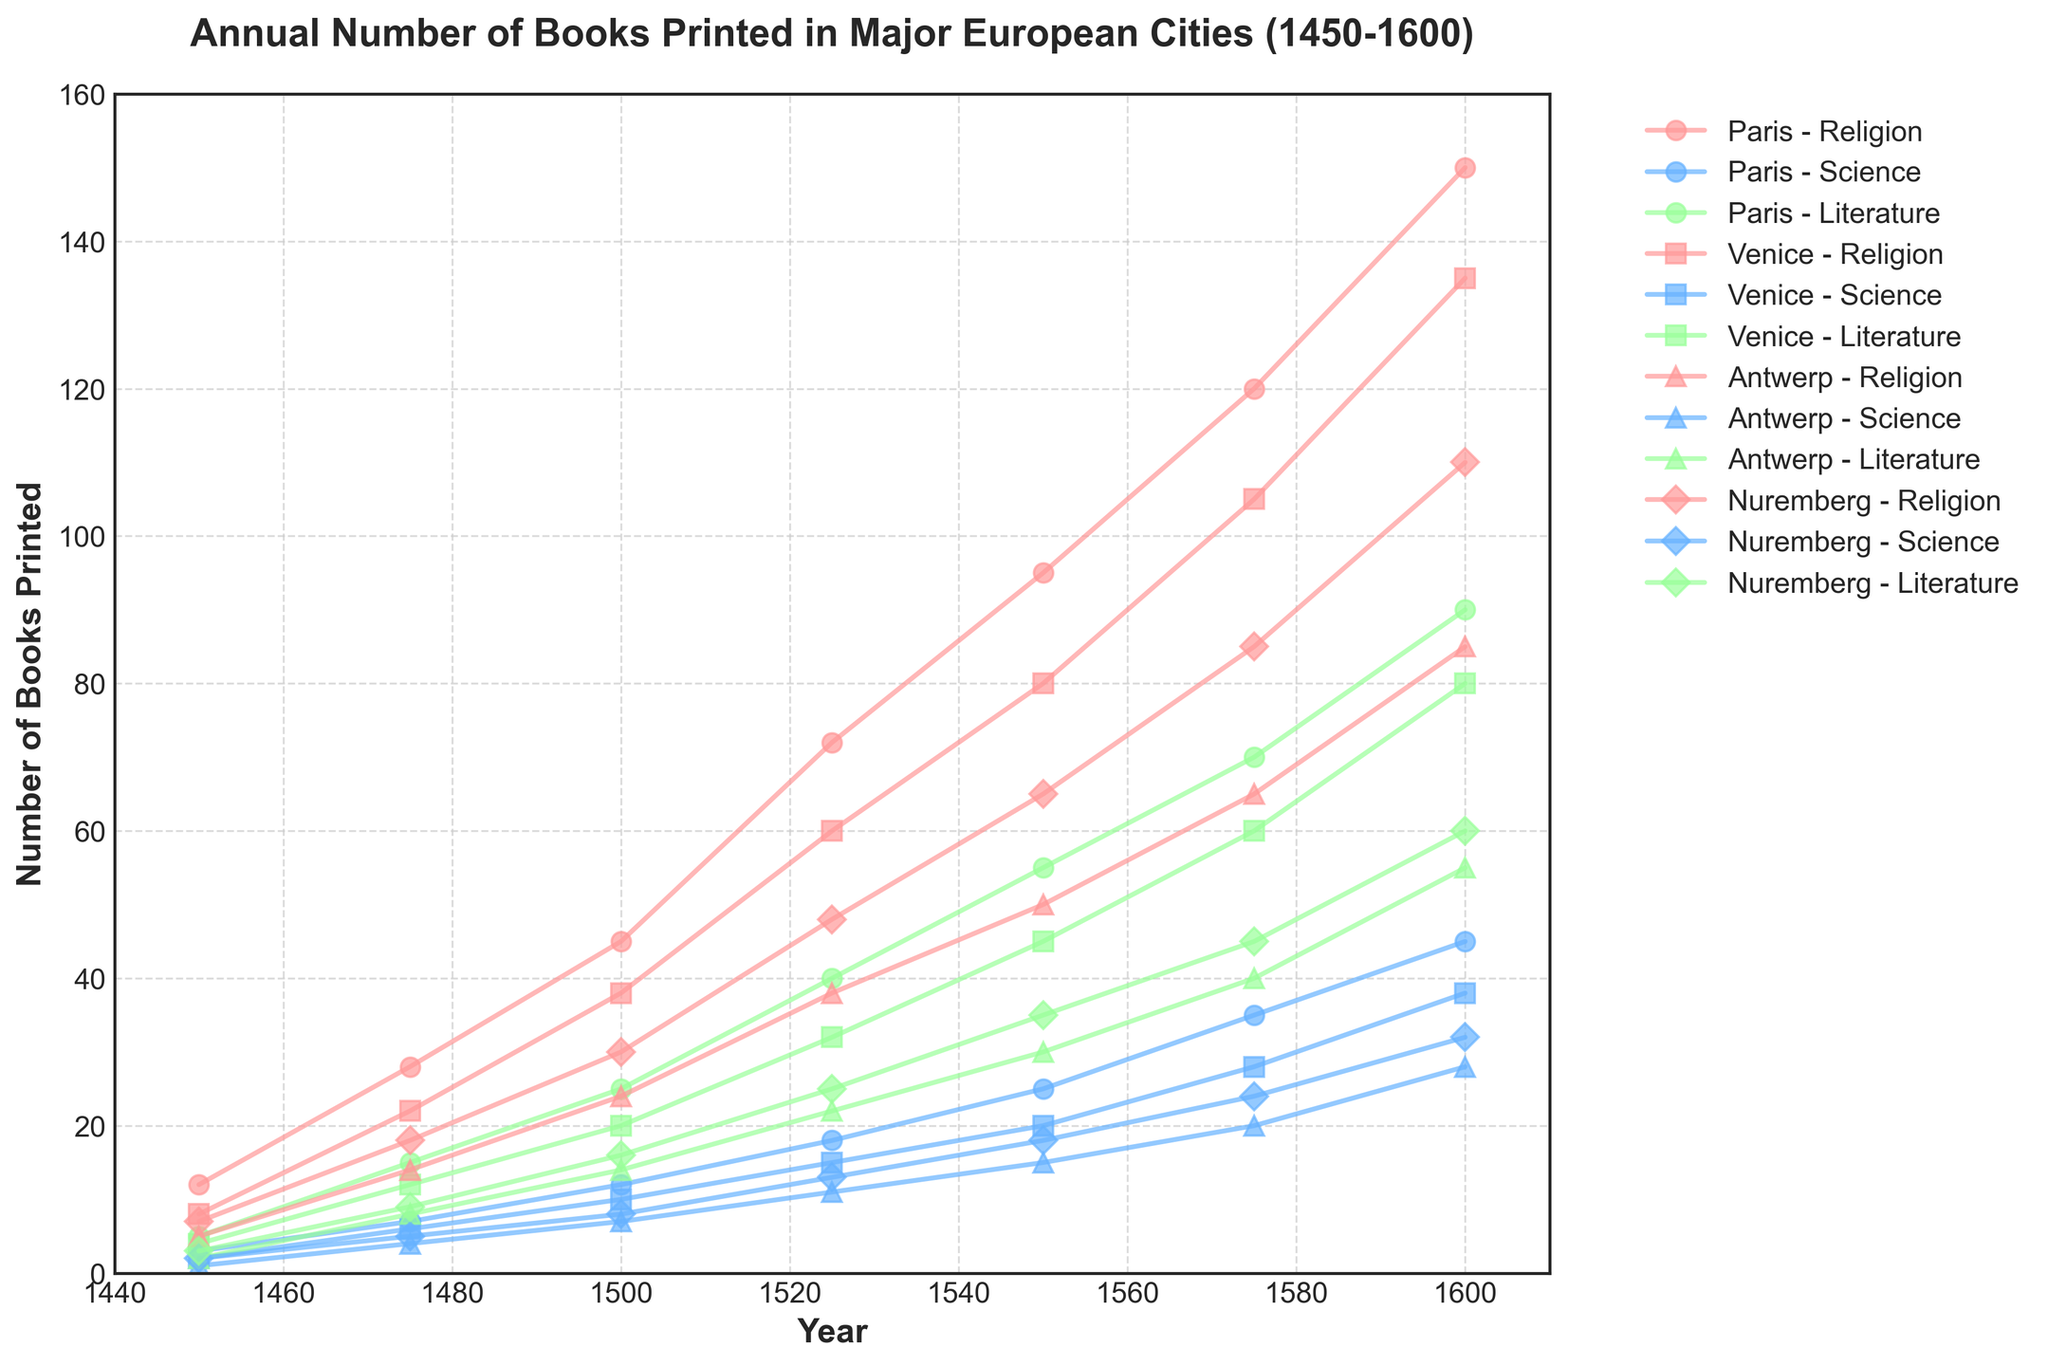What year did Paris print the most Science books? By looking at the line for Science books from Paris (indicated with a specific marker and color), the highest point on the y-axis corresponds to the year.
Answer: 1600 Throughout the years, which city had a higher number of Religious books printed, Venice or Nuremberg? Compare the lines representing Religious books for Venice and Nuremberg. Each year, identify which city's line is higher on the y-axis.
Answer: Venice In 1575, how many total books were printed in Antwerp across all categories? Add the number of Religion, Science, and Literature books in Antwerp for the year 1575: 65 (Religion) + 20 (Science) + 40 (Literature).
Answer: 125 Was the number of Literature books printed in Paris in 1500 higher or lower than in Nuremberg? Compare the data points for Literature books in Paris and Nuremberg in the year 1500: Paris had 25 and Nuremberg had 16.
Answer: Higher Which city saw the largest increase in Science books printed from 1450 to 1600? Compute the difference in the number of Science books for each city between 1450 and 1600. Compare these differences: Paris (45-3 = 42), Venice (38-2 = 36), Antwerp (28-1 = 27), Nuremberg (32-2 = 30).
Answer: Paris In which category did Antwerp print the least number of books in 1475? Look at the data for Antwerp in 1475 and identify the smallest number among Religion (14), Science (4), and Literature (8).
Answer: Science By how many books did the total number of books printed in Venice in 1550 exceed those printed in 1450? Calculate the total books printed in Venice for both years: in 1450 (8+2+4=14) and in 1550 (80+20+45=145). Find the difference: 145 - 14.
Answer: 131 Compare the number of Religious books printed in Nuremberg and Paris in 1525. Which city printed more, and by how much? Compare the data points for Religious books in Nuremberg (48) and Paris (72) in 1525. Subtract the smaller number from the larger to find the difference: 72 - 48.
Answer: Paris, by 24 